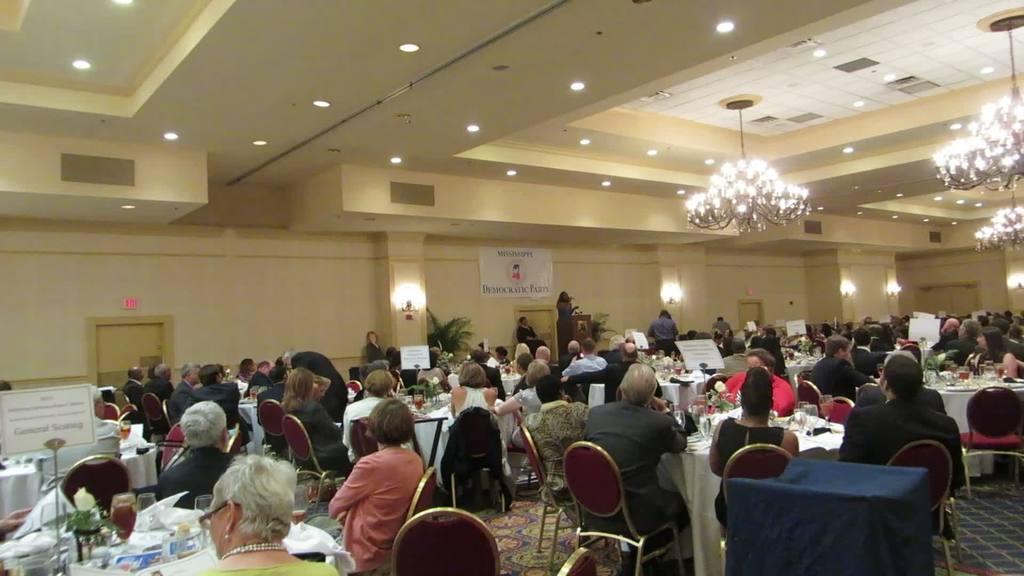How would you summarize this image in a sentence or two? The image is taken in the hall. In the center of the hall there is a lady standing there is a podium placed before her. At the bottom of the image there are many people sitting. There are tables. we can see glasses, plates and papers placed on the table. At the top there are lights and chandeliers. 